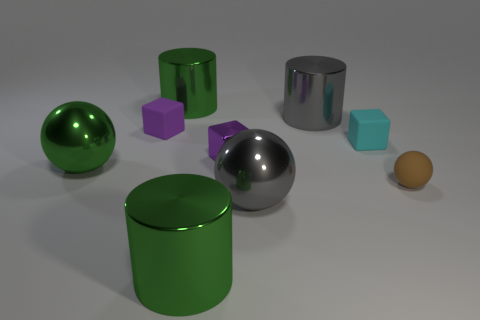There is a big thing that is on the left side of the gray sphere and in front of the tiny brown sphere; what material is it?
Provide a short and direct response. Metal. How many other objects are the same size as the gray shiny cylinder?
Ensure brevity in your answer.  4. The tiny shiny object has what color?
Give a very brief answer. Purple. There is a cylinder that is in front of the brown rubber ball; is its color the same as the big shiny sphere in front of the brown rubber object?
Offer a terse response. No. What size is the green metallic sphere?
Your answer should be compact. Large. There is a gray object behind the cyan matte thing; what is its size?
Keep it short and to the point. Large. There is a large thing that is on the left side of the small purple metal object and behind the cyan thing; what shape is it?
Provide a short and direct response. Cylinder. How many other objects are the same shape as the small cyan thing?
Keep it short and to the point. 2. What is the color of the metallic block that is the same size as the brown rubber object?
Make the answer very short. Purple. What number of objects are metal cubes or small purple cubes?
Provide a short and direct response. 2. 